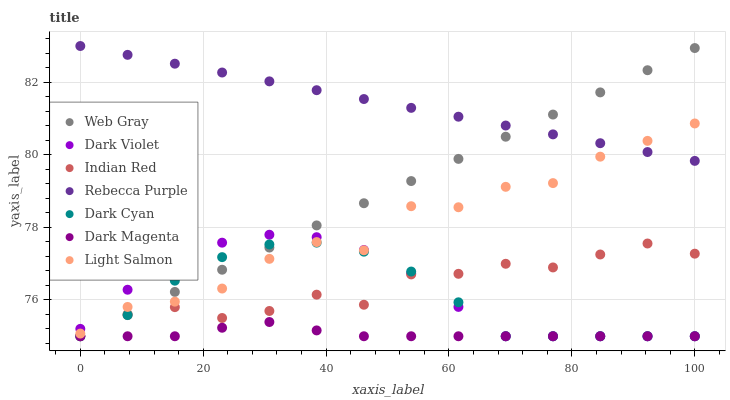Does Dark Magenta have the minimum area under the curve?
Answer yes or no. Yes. Does Rebecca Purple have the maximum area under the curve?
Answer yes or no. Yes. Does Web Gray have the minimum area under the curve?
Answer yes or no. No. Does Web Gray have the maximum area under the curve?
Answer yes or no. No. Is Web Gray the smoothest?
Answer yes or no. Yes. Is Light Salmon the roughest?
Answer yes or no. Yes. Is Dark Magenta the smoothest?
Answer yes or no. No. Is Dark Magenta the roughest?
Answer yes or no. No. Does Web Gray have the lowest value?
Answer yes or no. Yes. Does Rebecca Purple have the lowest value?
Answer yes or no. No. Does Rebecca Purple have the highest value?
Answer yes or no. Yes. Does Web Gray have the highest value?
Answer yes or no. No. Is Indian Red less than Rebecca Purple?
Answer yes or no. Yes. Is Light Salmon greater than Dark Magenta?
Answer yes or no. Yes. Does Dark Violet intersect Light Salmon?
Answer yes or no. Yes. Is Dark Violet less than Light Salmon?
Answer yes or no. No. Is Dark Violet greater than Light Salmon?
Answer yes or no. No. Does Indian Red intersect Rebecca Purple?
Answer yes or no. No. 